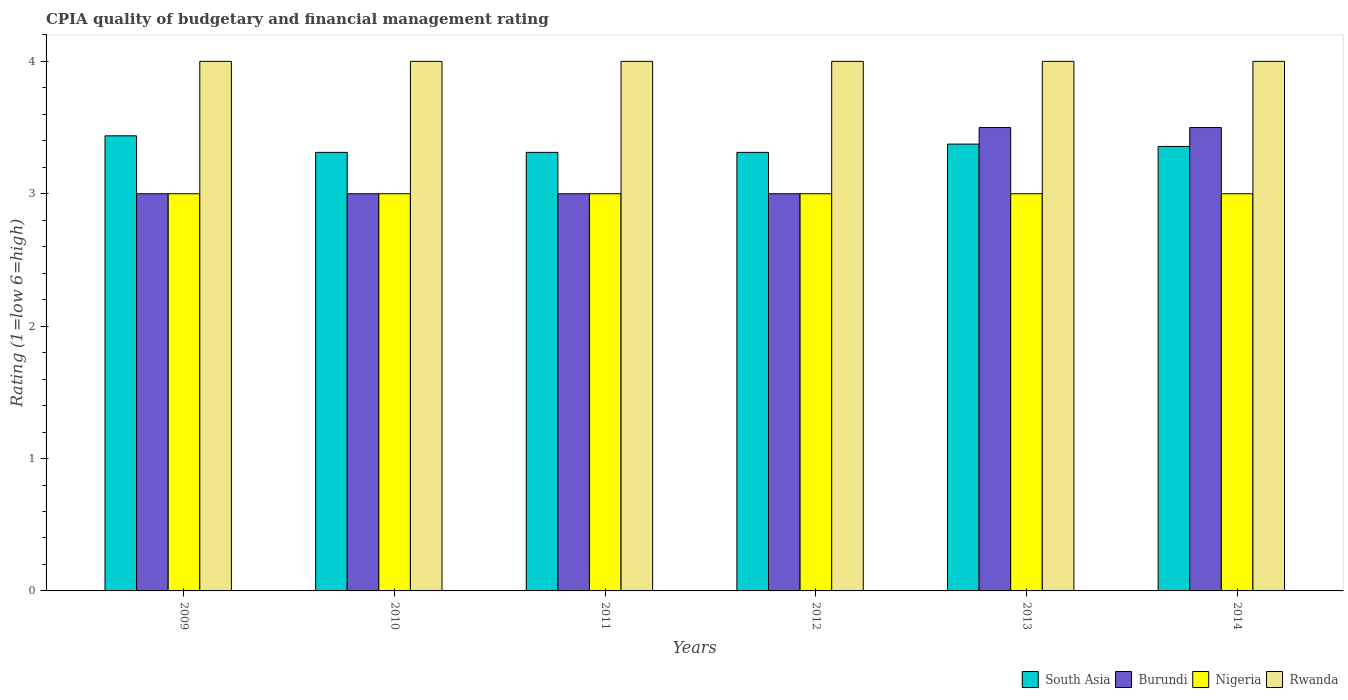Are the number of bars on each tick of the X-axis equal?
Offer a terse response. Yes. How many bars are there on the 6th tick from the left?
Make the answer very short. 4. How many bars are there on the 6th tick from the right?
Ensure brevity in your answer.  4. In how many cases, is the number of bars for a given year not equal to the number of legend labels?
Provide a succinct answer. 0. What is the CPIA rating in Rwanda in 2009?
Give a very brief answer. 4. Across all years, what is the maximum CPIA rating in South Asia?
Keep it short and to the point. 3.44. In which year was the CPIA rating in Rwanda maximum?
Offer a very short reply. 2009. In which year was the CPIA rating in Nigeria minimum?
Make the answer very short. 2009. What is the difference between the CPIA rating in Nigeria in 2011 and the CPIA rating in Rwanda in 2009?
Offer a terse response. -1. In the year 2012, what is the difference between the CPIA rating in Rwanda and CPIA rating in Burundi?
Ensure brevity in your answer.  1. What is the ratio of the CPIA rating in South Asia in 2013 to that in 2014?
Make the answer very short. 1.01. Is the CPIA rating in Nigeria in 2012 less than that in 2013?
Keep it short and to the point. No. Is the difference between the CPIA rating in Rwanda in 2010 and 2012 greater than the difference between the CPIA rating in Burundi in 2010 and 2012?
Your answer should be compact. No. In how many years, is the CPIA rating in Burundi greater than the average CPIA rating in Burundi taken over all years?
Provide a short and direct response. 2. Is it the case that in every year, the sum of the CPIA rating in South Asia and CPIA rating in Burundi is greater than the sum of CPIA rating in Nigeria and CPIA rating in Rwanda?
Provide a short and direct response. Yes. What does the 2nd bar from the left in 2011 represents?
Keep it short and to the point. Burundi. What does the 2nd bar from the right in 2013 represents?
Ensure brevity in your answer.  Nigeria. How many bars are there?
Provide a short and direct response. 24. Are all the bars in the graph horizontal?
Keep it short and to the point. No. Are the values on the major ticks of Y-axis written in scientific E-notation?
Offer a very short reply. No. Does the graph contain grids?
Provide a succinct answer. No. Where does the legend appear in the graph?
Keep it short and to the point. Bottom right. How many legend labels are there?
Keep it short and to the point. 4. What is the title of the graph?
Offer a terse response. CPIA quality of budgetary and financial management rating. What is the Rating (1=low 6=high) of South Asia in 2009?
Your answer should be very brief. 3.44. What is the Rating (1=low 6=high) in Nigeria in 2009?
Offer a terse response. 3. What is the Rating (1=low 6=high) in South Asia in 2010?
Provide a short and direct response. 3.31. What is the Rating (1=low 6=high) in South Asia in 2011?
Offer a very short reply. 3.31. What is the Rating (1=low 6=high) in Burundi in 2011?
Provide a short and direct response. 3. What is the Rating (1=low 6=high) in Rwanda in 2011?
Provide a succinct answer. 4. What is the Rating (1=low 6=high) of South Asia in 2012?
Offer a very short reply. 3.31. What is the Rating (1=low 6=high) of South Asia in 2013?
Your answer should be very brief. 3.38. What is the Rating (1=low 6=high) of Burundi in 2013?
Give a very brief answer. 3.5. What is the Rating (1=low 6=high) in Nigeria in 2013?
Keep it short and to the point. 3. What is the Rating (1=low 6=high) of Rwanda in 2013?
Your answer should be very brief. 4. What is the Rating (1=low 6=high) in South Asia in 2014?
Your answer should be compact. 3.36. What is the Rating (1=low 6=high) in Burundi in 2014?
Your answer should be compact. 3.5. What is the Rating (1=low 6=high) of Nigeria in 2014?
Offer a terse response. 3. What is the Rating (1=low 6=high) in Rwanda in 2014?
Your response must be concise. 4. Across all years, what is the maximum Rating (1=low 6=high) in South Asia?
Your answer should be compact. 3.44. Across all years, what is the maximum Rating (1=low 6=high) of Nigeria?
Provide a succinct answer. 3. Across all years, what is the maximum Rating (1=low 6=high) in Rwanda?
Offer a very short reply. 4. Across all years, what is the minimum Rating (1=low 6=high) in South Asia?
Offer a very short reply. 3.31. Across all years, what is the minimum Rating (1=low 6=high) in Burundi?
Provide a short and direct response. 3. Across all years, what is the minimum Rating (1=low 6=high) of Nigeria?
Offer a very short reply. 3. Across all years, what is the minimum Rating (1=low 6=high) of Rwanda?
Your answer should be compact. 4. What is the total Rating (1=low 6=high) in South Asia in the graph?
Ensure brevity in your answer.  20.11. What is the total Rating (1=low 6=high) of Nigeria in the graph?
Offer a terse response. 18. What is the difference between the Rating (1=low 6=high) in South Asia in 2009 and that in 2010?
Your answer should be compact. 0.12. What is the difference between the Rating (1=low 6=high) of Nigeria in 2009 and that in 2010?
Keep it short and to the point. 0. What is the difference between the Rating (1=low 6=high) in Rwanda in 2009 and that in 2010?
Provide a short and direct response. 0. What is the difference between the Rating (1=low 6=high) in South Asia in 2009 and that in 2011?
Offer a very short reply. 0.12. What is the difference between the Rating (1=low 6=high) in Burundi in 2009 and that in 2011?
Ensure brevity in your answer.  0. What is the difference between the Rating (1=low 6=high) in Nigeria in 2009 and that in 2011?
Offer a terse response. 0. What is the difference between the Rating (1=low 6=high) of South Asia in 2009 and that in 2012?
Ensure brevity in your answer.  0.12. What is the difference between the Rating (1=low 6=high) in Burundi in 2009 and that in 2012?
Your answer should be very brief. 0. What is the difference between the Rating (1=low 6=high) in Nigeria in 2009 and that in 2012?
Offer a very short reply. 0. What is the difference between the Rating (1=low 6=high) in South Asia in 2009 and that in 2013?
Make the answer very short. 0.06. What is the difference between the Rating (1=low 6=high) of Nigeria in 2009 and that in 2013?
Offer a terse response. 0. What is the difference between the Rating (1=low 6=high) of Rwanda in 2009 and that in 2013?
Keep it short and to the point. 0. What is the difference between the Rating (1=low 6=high) of South Asia in 2009 and that in 2014?
Offer a very short reply. 0.08. What is the difference between the Rating (1=low 6=high) in Nigeria in 2009 and that in 2014?
Provide a short and direct response. 0. What is the difference between the Rating (1=low 6=high) in Rwanda in 2009 and that in 2014?
Keep it short and to the point. 0. What is the difference between the Rating (1=low 6=high) in Burundi in 2010 and that in 2011?
Your answer should be very brief. 0. What is the difference between the Rating (1=low 6=high) in Rwanda in 2010 and that in 2011?
Your response must be concise. 0. What is the difference between the Rating (1=low 6=high) of South Asia in 2010 and that in 2013?
Make the answer very short. -0.06. What is the difference between the Rating (1=low 6=high) of Nigeria in 2010 and that in 2013?
Make the answer very short. 0. What is the difference between the Rating (1=low 6=high) of Rwanda in 2010 and that in 2013?
Your answer should be compact. 0. What is the difference between the Rating (1=low 6=high) in South Asia in 2010 and that in 2014?
Your response must be concise. -0.04. What is the difference between the Rating (1=low 6=high) in Nigeria in 2010 and that in 2014?
Your response must be concise. 0. What is the difference between the Rating (1=low 6=high) of South Asia in 2011 and that in 2012?
Provide a succinct answer. 0. What is the difference between the Rating (1=low 6=high) of Burundi in 2011 and that in 2012?
Your response must be concise. 0. What is the difference between the Rating (1=low 6=high) of South Asia in 2011 and that in 2013?
Make the answer very short. -0.06. What is the difference between the Rating (1=low 6=high) in Nigeria in 2011 and that in 2013?
Your answer should be compact. 0. What is the difference between the Rating (1=low 6=high) in Rwanda in 2011 and that in 2013?
Give a very brief answer. 0. What is the difference between the Rating (1=low 6=high) in South Asia in 2011 and that in 2014?
Make the answer very short. -0.04. What is the difference between the Rating (1=low 6=high) of Rwanda in 2011 and that in 2014?
Give a very brief answer. 0. What is the difference between the Rating (1=low 6=high) of South Asia in 2012 and that in 2013?
Offer a terse response. -0.06. What is the difference between the Rating (1=low 6=high) in Burundi in 2012 and that in 2013?
Provide a succinct answer. -0.5. What is the difference between the Rating (1=low 6=high) in Rwanda in 2012 and that in 2013?
Ensure brevity in your answer.  0. What is the difference between the Rating (1=low 6=high) of South Asia in 2012 and that in 2014?
Offer a very short reply. -0.04. What is the difference between the Rating (1=low 6=high) of Burundi in 2012 and that in 2014?
Your answer should be compact. -0.5. What is the difference between the Rating (1=low 6=high) in South Asia in 2013 and that in 2014?
Ensure brevity in your answer.  0.02. What is the difference between the Rating (1=low 6=high) of Nigeria in 2013 and that in 2014?
Make the answer very short. 0. What is the difference between the Rating (1=low 6=high) of Rwanda in 2013 and that in 2014?
Your answer should be very brief. 0. What is the difference between the Rating (1=low 6=high) of South Asia in 2009 and the Rating (1=low 6=high) of Burundi in 2010?
Give a very brief answer. 0.44. What is the difference between the Rating (1=low 6=high) in South Asia in 2009 and the Rating (1=low 6=high) in Nigeria in 2010?
Your response must be concise. 0.44. What is the difference between the Rating (1=low 6=high) of South Asia in 2009 and the Rating (1=low 6=high) of Rwanda in 2010?
Keep it short and to the point. -0.56. What is the difference between the Rating (1=low 6=high) in Burundi in 2009 and the Rating (1=low 6=high) in Rwanda in 2010?
Provide a succinct answer. -1. What is the difference between the Rating (1=low 6=high) of South Asia in 2009 and the Rating (1=low 6=high) of Burundi in 2011?
Provide a succinct answer. 0.44. What is the difference between the Rating (1=low 6=high) of South Asia in 2009 and the Rating (1=low 6=high) of Nigeria in 2011?
Your answer should be very brief. 0.44. What is the difference between the Rating (1=low 6=high) in South Asia in 2009 and the Rating (1=low 6=high) in Rwanda in 2011?
Ensure brevity in your answer.  -0.56. What is the difference between the Rating (1=low 6=high) in Burundi in 2009 and the Rating (1=low 6=high) in Rwanda in 2011?
Provide a short and direct response. -1. What is the difference between the Rating (1=low 6=high) in Nigeria in 2009 and the Rating (1=low 6=high) in Rwanda in 2011?
Offer a very short reply. -1. What is the difference between the Rating (1=low 6=high) in South Asia in 2009 and the Rating (1=low 6=high) in Burundi in 2012?
Provide a short and direct response. 0.44. What is the difference between the Rating (1=low 6=high) of South Asia in 2009 and the Rating (1=low 6=high) of Nigeria in 2012?
Your answer should be compact. 0.44. What is the difference between the Rating (1=low 6=high) in South Asia in 2009 and the Rating (1=low 6=high) in Rwanda in 2012?
Your response must be concise. -0.56. What is the difference between the Rating (1=low 6=high) in Burundi in 2009 and the Rating (1=low 6=high) in Rwanda in 2012?
Your response must be concise. -1. What is the difference between the Rating (1=low 6=high) of Nigeria in 2009 and the Rating (1=low 6=high) of Rwanda in 2012?
Make the answer very short. -1. What is the difference between the Rating (1=low 6=high) in South Asia in 2009 and the Rating (1=low 6=high) in Burundi in 2013?
Offer a very short reply. -0.06. What is the difference between the Rating (1=low 6=high) of South Asia in 2009 and the Rating (1=low 6=high) of Nigeria in 2013?
Offer a terse response. 0.44. What is the difference between the Rating (1=low 6=high) in South Asia in 2009 and the Rating (1=low 6=high) in Rwanda in 2013?
Provide a succinct answer. -0.56. What is the difference between the Rating (1=low 6=high) of Burundi in 2009 and the Rating (1=low 6=high) of Rwanda in 2013?
Make the answer very short. -1. What is the difference between the Rating (1=low 6=high) in Nigeria in 2009 and the Rating (1=low 6=high) in Rwanda in 2013?
Your response must be concise. -1. What is the difference between the Rating (1=low 6=high) in South Asia in 2009 and the Rating (1=low 6=high) in Burundi in 2014?
Make the answer very short. -0.06. What is the difference between the Rating (1=low 6=high) of South Asia in 2009 and the Rating (1=low 6=high) of Nigeria in 2014?
Ensure brevity in your answer.  0.44. What is the difference between the Rating (1=low 6=high) of South Asia in 2009 and the Rating (1=low 6=high) of Rwanda in 2014?
Provide a short and direct response. -0.56. What is the difference between the Rating (1=low 6=high) in Burundi in 2009 and the Rating (1=low 6=high) in Rwanda in 2014?
Your answer should be very brief. -1. What is the difference between the Rating (1=low 6=high) in Nigeria in 2009 and the Rating (1=low 6=high) in Rwanda in 2014?
Your answer should be very brief. -1. What is the difference between the Rating (1=low 6=high) in South Asia in 2010 and the Rating (1=low 6=high) in Burundi in 2011?
Give a very brief answer. 0.31. What is the difference between the Rating (1=low 6=high) of South Asia in 2010 and the Rating (1=low 6=high) of Nigeria in 2011?
Keep it short and to the point. 0.31. What is the difference between the Rating (1=low 6=high) in South Asia in 2010 and the Rating (1=low 6=high) in Rwanda in 2011?
Provide a succinct answer. -0.69. What is the difference between the Rating (1=low 6=high) of Burundi in 2010 and the Rating (1=low 6=high) of Rwanda in 2011?
Offer a terse response. -1. What is the difference between the Rating (1=low 6=high) in Nigeria in 2010 and the Rating (1=low 6=high) in Rwanda in 2011?
Keep it short and to the point. -1. What is the difference between the Rating (1=low 6=high) in South Asia in 2010 and the Rating (1=low 6=high) in Burundi in 2012?
Provide a short and direct response. 0.31. What is the difference between the Rating (1=low 6=high) of South Asia in 2010 and the Rating (1=low 6=high) of Nigeria in 2012?
Keep it short and to the point. 0.31. What is the difference between the Rating (1=low 6=high) in South Asia in 2010 and the Rating (1=low 6=high) in Rwanda in 2012?
Your response must be concise. -0.69. What is the difference between the Rating (1=low 6=high) of Nigeria in 2010 and the Rating (1=low 6=high) of Rwanda in 2012?
Your response must be concise. -1. What is the difference between the Rating (1=low 6=high) in South Asia in 2010 and the Rating (1=low 6=high) in Burundi in 2013?
Make the answer very short. -0.19. What is the difference between the Rating (1=low 6=high) in South Asia in 2010 and the Rating (1=low 6=high) in Nigeria in 2013?
Keep it short and to the point. 0.31. What is the difference between the Rating (1=low 6=high) in South Asia in 2010 and the Rating (1=low 6=high) in Rwanda in 2013?
Ensure brevity in your answer.  -0.69. What is the difference between the Rating (1=low 6=high) of Burundi in 2010 and the Rating (1=low 6=high) of Nigeria in 2013?
Provide a succinct answer. 0. What is the difference between the Rating (1=low 6=high) of Nigeria in 2010 and the Rating (1=low 6=high) of Rwanda in 2013?
Keep it short and to the point. -1. What is the difference between the Rating (1=low 6=high) of South Asia in 2010 and the Rating (1=low 6=high) of Burundi in 2014?
Offer a very short reply. -0.19. What is the difference between the Rating (1=low 6=high) in South Asia in 2010 and the Rating (1=low 6=high) in Nigeria in 2014?
Make the answer very short. 0.31. What is the difference between the Rating (1=low 6=high) in South Asia in 2010 and the Rating (1=low 6=high) in Rwanda in 2014?
Your answer should be compact. -0.69. What is the difference between the Rating (1=low 6=high) of Burundi in 2010 and the Rating (1=low 6=high) of Rwanda in 2014?
Your answer should be very brief. -1. What is the difference between the Rating (1=low 6=high) in South Asia in 2011 and the Rating (1=low 6=high) in Burundi in 2012?
Offer a terse response. 0.31. What is the difference between the Rating (1=low 6=high) of South Asia in 2011 and the Rating (1=low 6=high) of Nigeria in 2012?
Make the answer very short. 0.31. What is the difference between the Rating (1=low 6=high) in South Asia in 2011 and the Rating (1=low 6=high) in Rwanda in 2012?
Your answer should be compact. -0.69. What is the difference between the Rating (1=low 6=high) of South Asia in 2011 and the Rating (1=low 6=high) of Burundi in 2013?
Make the answer very short. -0.19. What is the difference between the Rating (1=low 6=high) of South Asia in 2011 and the Rating (1=low 6=high) of Nigeria in 2013?
Offer a terse response. 0.31. What is the difference between the Rating (1=low 6=high) of South Asia in 2011 and the Rating (1=low 6=high) of Rwanda in 2013?
Keep it short and to the point. -0.69. What is the difference between the Rating (1=low 6=high) of Burundi in 2011 and the Rating (1=low 6=high) of Rwanda in 2013?
Offer a terse response. -1. What is the difference between the Rating (1=low 6=high) of Nigeria in 2011 and the Rating (1=low 6=high) of Rwanda in 2013?
Provide a succinct answer. -1. What is the difference between the Rating (1=low 6=high) in South Asia in 2011 and the Rating (1=low 6=high) in Burundi in 2014?
Your answer should be compact. -0.19. What is the difference between the Rating (1=low 6=high) in South Asia in 2011 and the Rating (1=low 6=high) in Nigeria in 2014?
Your answer should be compact. 0.31. What is the difference between the Rating (1=low 6=high) of South Asia in 2011 and the Rating (1=low 6=high) of Rwanda in 2014?
Offer a terse response. -0.69. What is the difference between the Rating (1=low 6=high) in Burundi in 2011 and the Rating (1=low 6=high) in Nigeria in 2014?
Keep it short and to the point. 0. What is the difference between the Rating (1=low 6=high) in Nigeria in 2011 and the Rating (1=low 6=high) in Rwanda in 2014?
Provide a succinct answer. -1. What is the difference between the Rating (1=low 6=high) of South Asia in 2012 and the Rating (1=low 6=high) of Burundi in 2013?
Make the answer very short. -0.19. What is the difference between the Rating (1=low 6=high) of South Asia in 2012 and the Rating (1=low 6=high) of Nigeria in 2013?
Provide a short and direct response. 0.31. What is the difference between the Rating (1=low 6=high) in South Asia in 2012 and the Rating (1=low 6=high) in Rwanda in 2013?
Your answer should be very brief. -0.69. What is the difference between the Rating (1=low 6=high) of Burundi in 2012 and the Rating (1=low 6=high) of Nigeria in 2013?
Provide a succinct answer. 0. What is the difference between the Rating (1=low 6=high) in Nigeria in 2012 and the Rating (1=low 6=high) in Rwanda in 2013?
Your response must be concise. -1. What is the difference between the Rating (1=low 6=high) in South Asia in 2012 and the Rating (1=low 6=high) in Burundi in 2014?
Your answer should be compact. -0.19. What is the difference between the Rating (1=low 6=high) of South Asia in 2012 and the Rating (1=low 6=high) of Nigeria in 2014?
Your response must be concise. 0.31. What is the difference between the Rating (1=low 6=high) in South Asia in 2012 and the Rating (1=low 6=high) in Rwanda in 2014?
Provide a short and direct response. -0.69. What is the difference between the Rating (1=low 6=high) in Burundi in 2012 and the Rating (1=low 6=high) in Rwanda in 2014?
Provide a short and direct response. -1. What is the difference between the Rating (1=low 6=high) in Nigeria in 2012 and the Rating (1=low 6=high) in Rwanda in 2014?
Your answer should be very brief. -1. What is the difference between the Rating (1=low 6=high) of South Asia in 2013 and the Rating (1=low 6=high) of Burundi in 2014?
Your answer should be very brief. -0.12. What is the difference between the Rating (1=low 6=high) of South Asia in 2013 and the Rating (1=low 6=high) of Nigeria in 2014?
Provide a succinct answer. 0.38. What is the difference between the Rating (1=low 6=high) of South Asia in 2013 and the Rating (1=low 6=high) of Rwanda in 2014?
Your answer should be compact. -0.62. What is the difference between the Rating (1=low 6=high) of Burundi in 2013 and the Rating (1=low 6=high) of Nigeria in 2014?
Make the answer very short. 0.5. What is the difference between the Rating (1=low 6=high) in Burundi in 2013 and the Rating (1=low 6=high) in Rwanda in 2014?
Give a very brief answer. -0.5. What is the average Rating (1=low 6=high) of South Asia per year?
Ensure brevity in your answer.  3.35. What is the average Rating (1=low 6=high) of Burundi per year?
Provide a short and direct response. 3.17. What is the average Rating (1=low 6=high) of Nigeria per year?
Ensure brevity in your answer.  3. In the year 2009, what is the difference between the Rating (1=low 6=high) in South Asia and Rating (1=low 6=high) in Burundi?
Ensure brevity in your answer.  0.44. In the year 2009, what is the difference between the Rating (1=low 6=high) in South Asia and Rating (1=low 6=high) in Nigeria?
Provide a succinct answer. 0.44. In the year 2009, what is the difference between the Rating (1=low 6=high) of South Asia and Rating (1=low 6=high) of Rwanda?
Provide a short and direct response. -0.56. In the year 2009, what is the difference between the Rating (1=low 6=high) of Burundi and Rating (1=low 6=high) of Rwanda?
Provide a succinct answer. -1. In the year 2009, what is the difference between the Rating (1=low 6=high) of Nigeria and Rating (1=low 6=high) of Rwanda?
Provide a short and direct response. -1. In the year 2010, what is the difference between the Rating (1=low 6=high) in South Asia and Rating (1=low 6=high) in Burundi?
Offer a very short reply. 0.31. In the year 2010, what is the difference between the Rating (1=low 6=high) of South Asia and Rating (1=low 6=high) of Nigeria?
Make the answer very short. 0.31. In the year 2010, what is the difference between the Rating (1=low 6=high) in South Asia and Rating (1=low 6=high) in Rwanda?
Provide a short and direct response. -0.69. In the year 2010, what is the difference between the Rating (1=low 6=high) of Burundi and Rating (1=low 6=high) of Nigeria?
Keep it short and to the point. 0. In the year 2011, what is the difference between the Rating (1=low 6=high) in South Asia and Rating (1=low 6=high) in Burundi?
Your response must be concise. 0.31. In the year 2011, what is the difference between the Rating (1=low 6=high) of South Asia and Rating (1=low 6=high) of Nigeria?
Keep it short and to the point. 0.31. In the year 2011, what is the difference between the Rating (1=low 6=high) of South Asia and Rating (1=low 6=high) of Rwanda?
Your response must be concise. -0.69. In the year 2011, what is the difference between the Rating (1=low 6=high) in Burundi and Rating (1=low 6=high) in Nigeria?
Provide a short and direct response. 0. In the year 2011, what is the difference between the Rating (1=low 6=high) of Nigeria and Rating (1=low 6=high) of Rwanda?
Offer a terse response. -1. In the year 2012, what is the difference between the Rating (1=low 6=high) of South Asia and Rating (1=low 6=high) of Burundi?
Offer a terse response. 0.31. In the year 2012, what is the difference between the Rating (1=low 6=high) of South Asia and Rating (1=low 6=high) of Nigeria?
Ensure brevity in your answer.  0.31. In the year 2012, what is the difference between the Rating (1=low 6=high) of South Asia and Rating (1=low 6=high) of Rwanda?
Keep it short and to the point. -0.69. In the year 2012, what is the difference between the Rating (1=low 6=high) in Nigeria and Rating (1=low 6=high) in Rwanda?
Your response must be concise. -1. In the year 2013, what is the difference between the Rating (1=low 6=high) in South Asia and Rating (1=low 6=high) in Burundi?
Offer a very short reply. -0.12. In the year 2013, what is the difference between the Rating (1=low 6=high) in South Asia and Rating (1=low 6=high) in Rwanda?
Offer a terse response. -0.62. In the year 2013, what is the difference between the Rating (1=low 6=high) of Nigeria and Rating (1=low 6=high) of Rwanda?
Offer a terse response. -1. In the year 2014, what is the difference between the Rating (1=low 6=high) in South Asia and Rating (1=low 6=high) in Burundi?
Offer a terse response. -0.14. In the year 2014, what is the difference between the Rating (1=low 6=high) of South Asia and Rating (1=low 6=high) of Nigeria?
Keep it short and to the point. 0.36. In the year 2014, what is the difference between the Rating (1=low 6=high) in South Asia and Rating (1=low 6=high) in Rwanda?
Your answer should be compact. -0.64. In the year 2014, what is the difference between the Rating (1=low 6=high) in Burundi and Rating (1=low 6=high) in Nigeria?
Offer a very short reply. 0.5. In the year 2014, what is the difference between the Rating (1=low 6=high) in Burundi and Rating (1=low 6=high) in Rwanda?
Your response must be concise. -0.5. What is the ratio of the Rating (1=low 6=high) in South Asia in 2009 to that in 2010?
Your answer should be very brief. 1.04. What is the ratio of the Rating (1=low 6=high) in Burundi in 2009 to that in 2010?
Make the answer very short. 1. What is the ratio of the Rating (1=low 6=high) in Nigeria in 2009 to that in 2010?
Offer a very short reply. 1. What is the ratio of the Rating (1=low 6=high) of Rwanda in 2009 to that in 2010?
Your response must be concise. 1. What is the ratio of the Rating (1=low 6=high) of South Asia in 2009 to that in 2011?
Provide a succinct answer. 1.04. What is the ratio of the Rating (1=low 6=high) in Burundi in 2009 to that in 2011?
Provide a short and direct response. 1. What is the ratio of the Rating (1=low 6=high) in Nigeria in 2009 to that in 2011?
Your response must be concise. 1. What is the ratio of the Rating (1=low 6=high) in South Asia in 2009 to that in 2012?
Provide a succinct answer. 1.04. What is the ratio of the Rating (1=low 6=high) of Burundi in 2009 to that in 2012?
Your answer should be very brief. 1. What is the ratio of the Rating (1=low 6=high) in Rwanda in 2009 to that in 2012?
Make the answer very short. 1. What is the ratio of the Rating (1=low 6=high) of South Asia in 2009 to that in 2013?
Provide a short and direct response. 1.02. What is the ratio of the Rating (1=low 6=high) in Nigeria in 2009 to that in 2013?
Make the answer very short. 1. What is the ratio of the Rating (1=low 6=high) of South Asia in 2009 to that in 2014?
Provide a succinct answer. 1.02. What is the ratio of the Rating (1=low 6=high) in Rwanda in 2009 to that in 2014?
Your response must be concise. 1. What is the ratio of the Rating (1=low 6=high) in South Asia in 2010 to that in 2011?
Ensure brevity in your answer.  1. What is the ratio of the Rating (1=low 6=high) in Burundi in 2010 to that in 2011?
Keep it short and to the point. 1. What is the ratio of the Rating (1=low 6=high) of South Asia in 2010 to that in 2012?
Make the answer very short. 1. What is the ratio of the Rating (1=low 6=high) in Nigeria in 2010 to that in 2012?
Offer a very short reply. 1. What is the ratio of the Rating (1=low 6=high) of South Asia in 2010 to that in 2013?
Ensure brevity in your answer.  0.98. What is the ratio of the Rating (1=low 6=high) in Rwanda in 2010 to that in 2013?
Give a very brief answer. 1. What is the ratio of the Rating (1=low 6=high) in South Asia in 2010 to that in 2014?
Provide a short and direct response. 0.99. What is the ratio of the Rating (1=low 6=high) in Burundi in 2010 to that in 2014?
Give a very brief answer. 0.86. What is the ratio of the Rating (1=low 6=high) of South Asia in 2011 to that in 2012?
Provide a short and direct response. 1. What is the ratio of the Rating (1=low 6=high) in Nigeria in 2011 to that in 2012?
Make the answer very short. 1. What is the ratio of the Rating (1=low 6=high) of South Asia in 2011 to that in 2013?
Offer a very short reply. 0.98. What is the ratio of the Rating (1=low 6=high) in Burundi in 2011 to that in 2013?
Your answer should be very brief. 0.86. What is the ratio of the Rating (1=low 6=high) of South Asia in 2011 to that in 2014?
Provide a succinct answer. 0.99. What is the ratio of the Rating (1=low 6=high) of Burundi in 2011 to that in 2014?
Offer a very short reply. 0.86. What is the ratio of the Rating (1=low 6=high) in Rwanda in 2011 to that in 2014?
Your response must be concise. 1. What is the ratio of the Rating (1=low 6=high) of South Asia in 2012 to that in 2013?
Make the answer very short. 0.98. What is the ratio of the Rating (1=low 6=high) in South Asia in 2012 to that in 2014?
Offer a very short reply. 0.99. What is the ratio of the Rating (1=low 6=high) of Burundi in 2012 to that in 2014?
Your answer should be very brief. 0.86. What is the ratio of the Rating (1=low 6=high) in Rwanda in 2012 to that in 2014?
Make the answer very short. 1. What is the ratio of the Rating (1=low 6=high) in South Asia in 2013 to that in 2014?
Offer a terse response. 1.01. What is the ratio of the Rating (1=low 6=high) in Burundi in 2013 to that in 2014?
Offer a very short reply. 1. What is the difference between the highest and the second highest Rating (1=low 6=high) in South Asia?
Your response must be concise. 0.06. What is the difference between the highest and the second highest Rating (1=low 6=high) in Burundi?
Offer a terse response. 0. What is the difference between the highest and the second highest Rating (1=low 6=high) in Nigeria?
Your answer should be compact. 0. What is the difference between the highest and the lowest Rating (1=low 6=high) in South Asia?
Offer a terse response. 0.12. What is the difference between the highest and the lowest Rating (1=low 6=high) of Nigeria?
Provide a succinct answer. 0. 